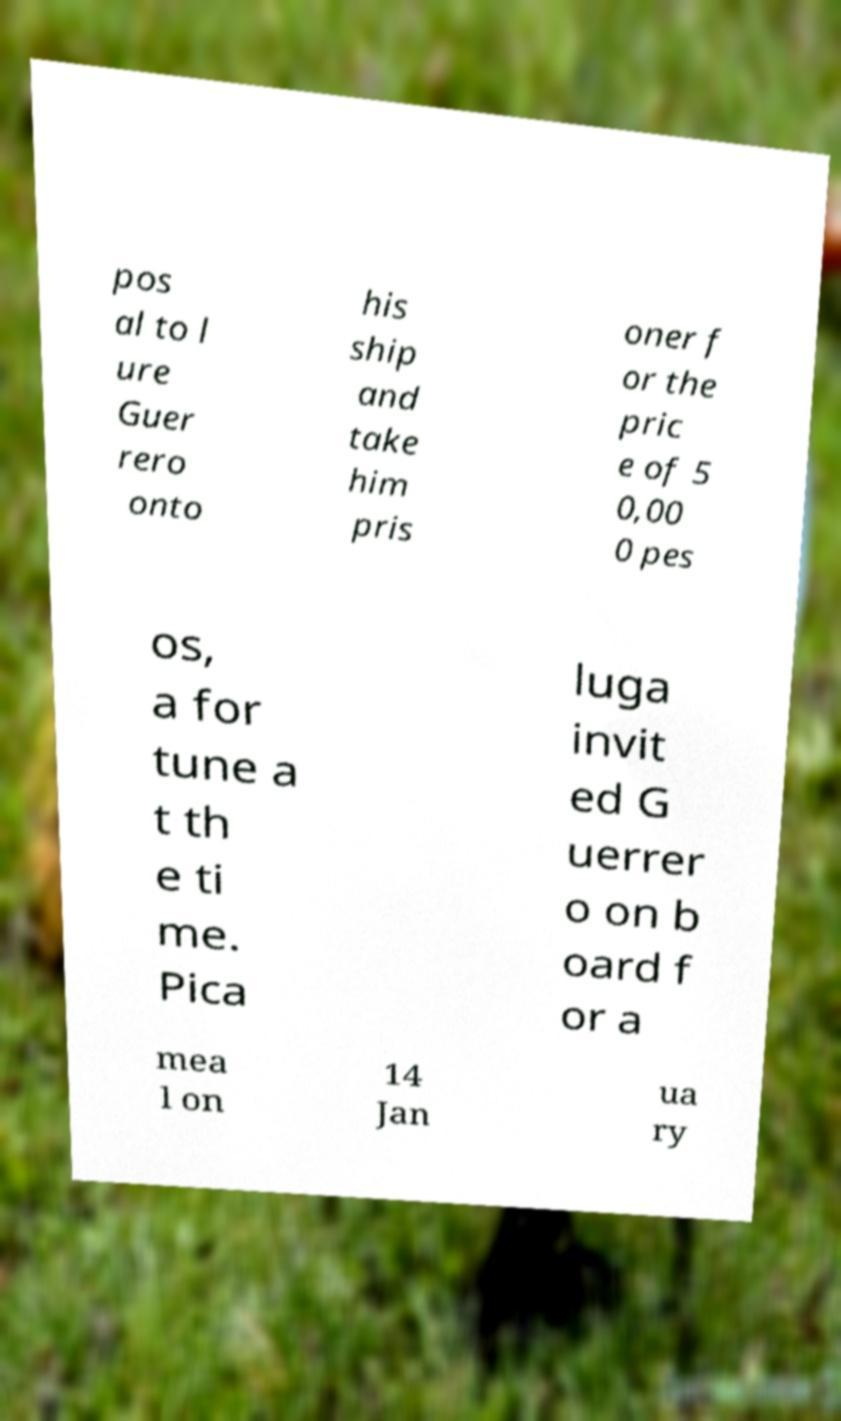What messages or text are displayed in this image? I need them in a readable, typed format. pos al to l ure Guer rero onto his ship and take him pris oner f or the pric e of 5 0,00 0 pes os, a for tune a t th e ti me. Pica luga invit ed G uerrer o on b oard f or a mea l on 14 Jan ua ry 